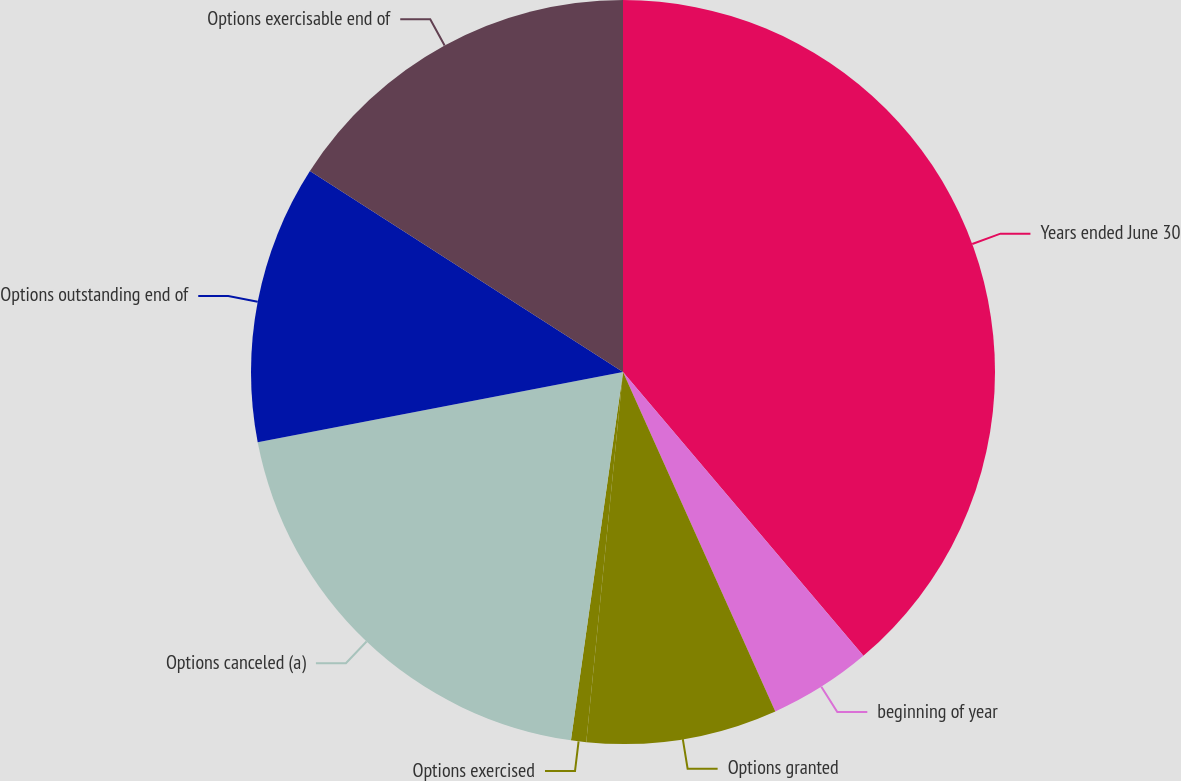<chart> <loc_0><loc_0><loc_500><loc_500><pie_chart><fcel>Years ended June 30<fcel>beginning of year<fcel>Options granted<fcel>Options exercised<fcel>Options canceled (a)<fcel>Options outstanding end of<fcel>Options exercisable end of<nl><fcel>38.82%<fcel>4.47%<fcel>8.29%<fcel>0.66%<fcel>19.74%<fcel>12.11%<fcel>15.92%<nl></chart> 